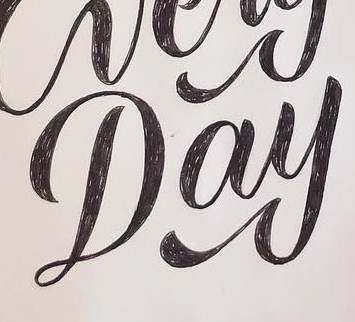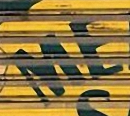Read the text from these images in sequence, separated by a semicolon. Day; ME 